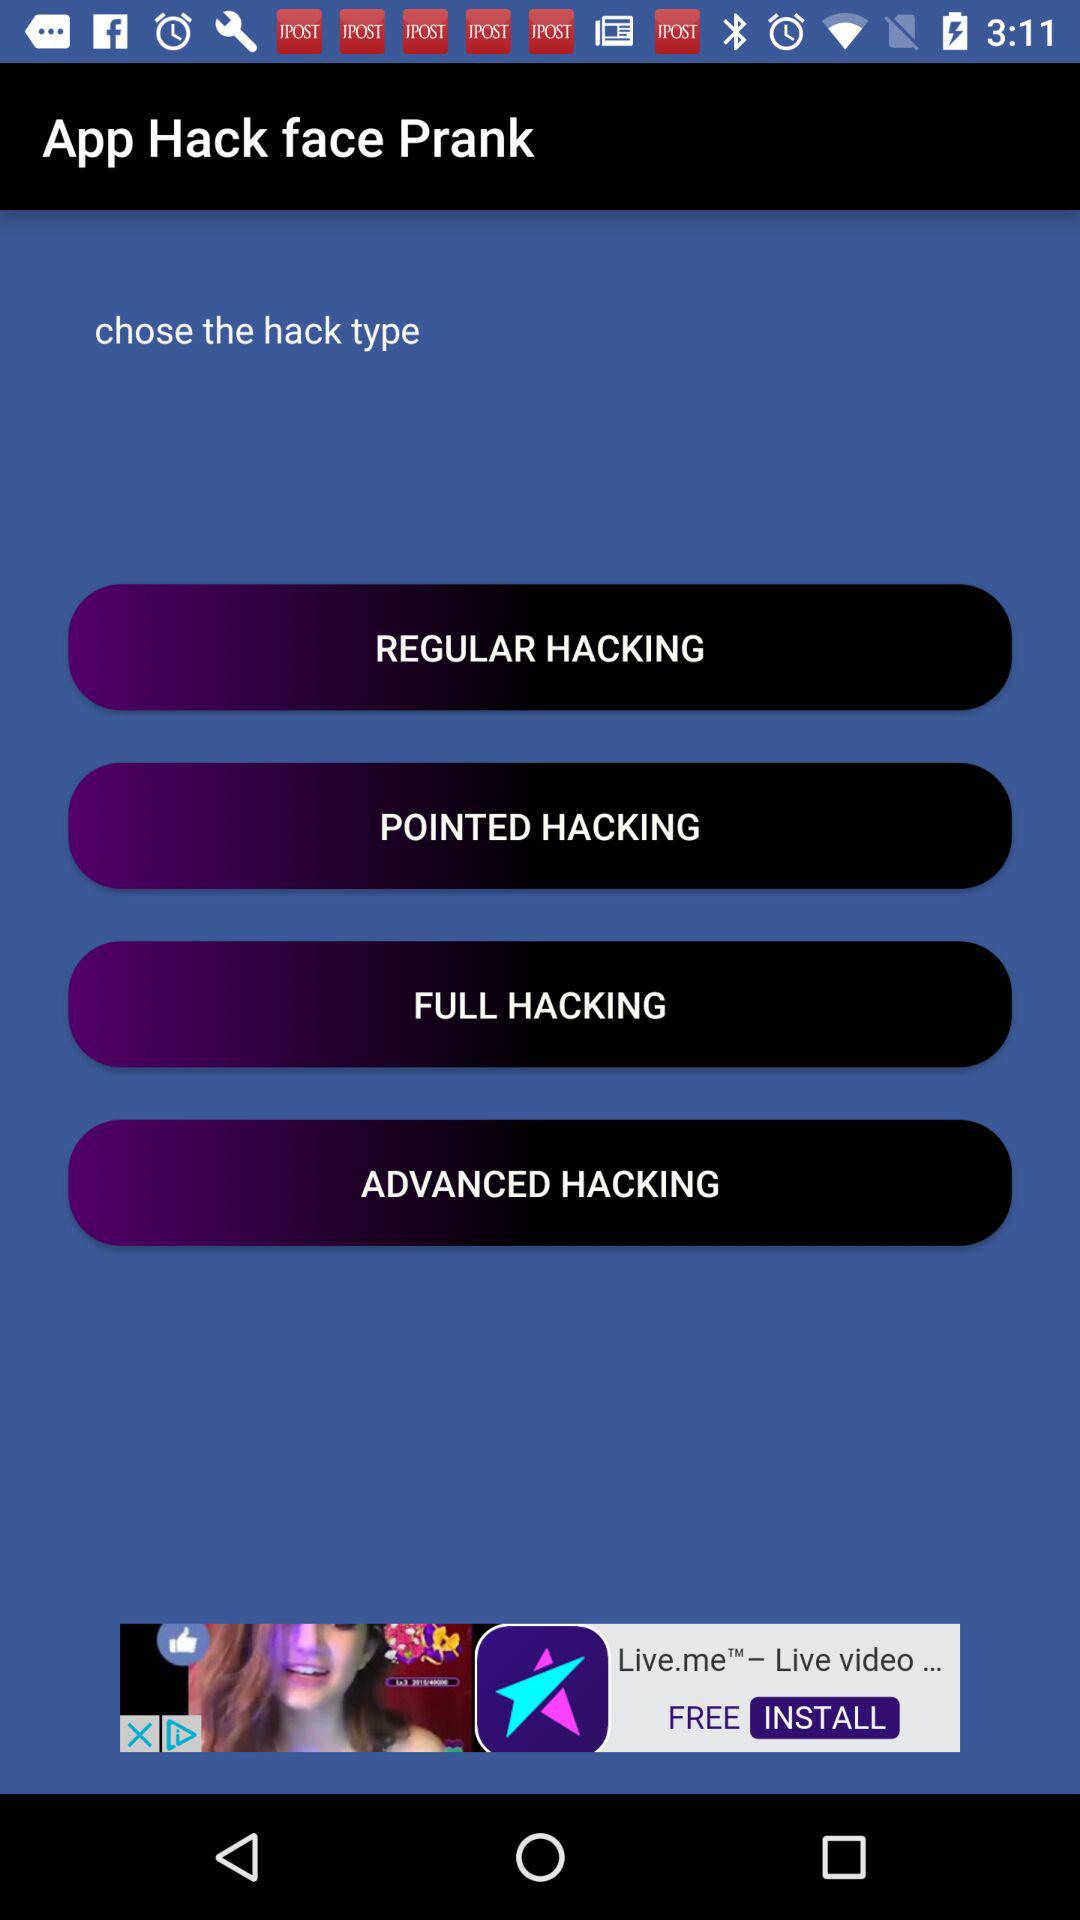What is the name of the application? The name of the application is "App Hack face Prank". 